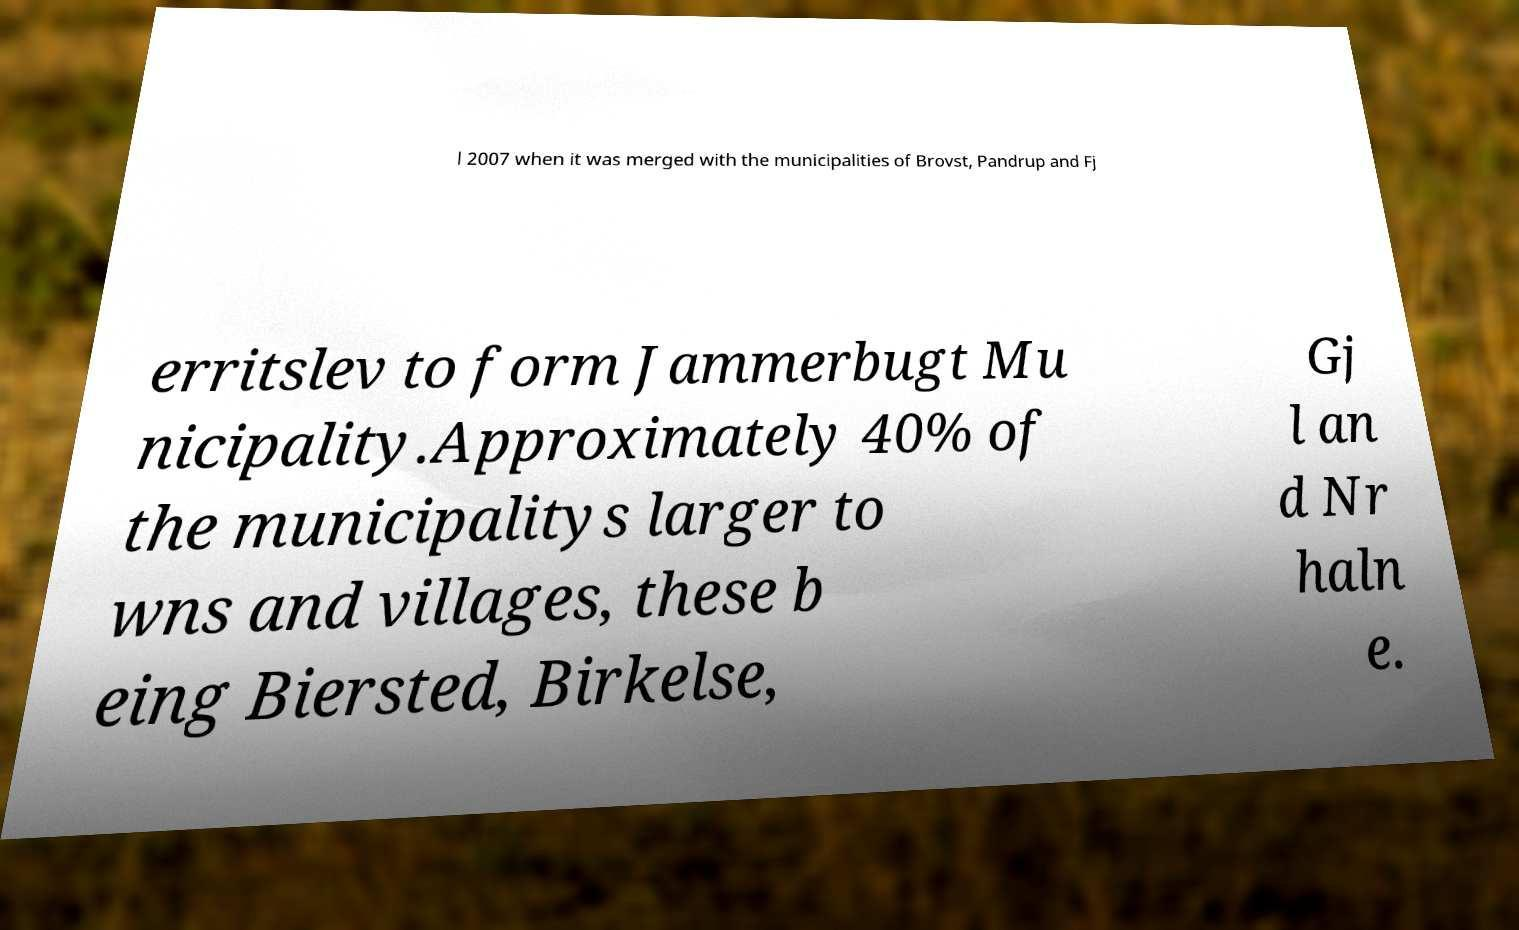There's text embedded in this image that I need extracted. Can you transcribe it verbatim? l 2007 when it was merged with the municipalities of Brovst, Pandrup and Fj erritslev to form Jammerbugt Mu nicipality.Approximately 40% of the municipalitys larger to wns and villages, these b eing Biersted, Birkelse, Gj l an d Nr haln e. 